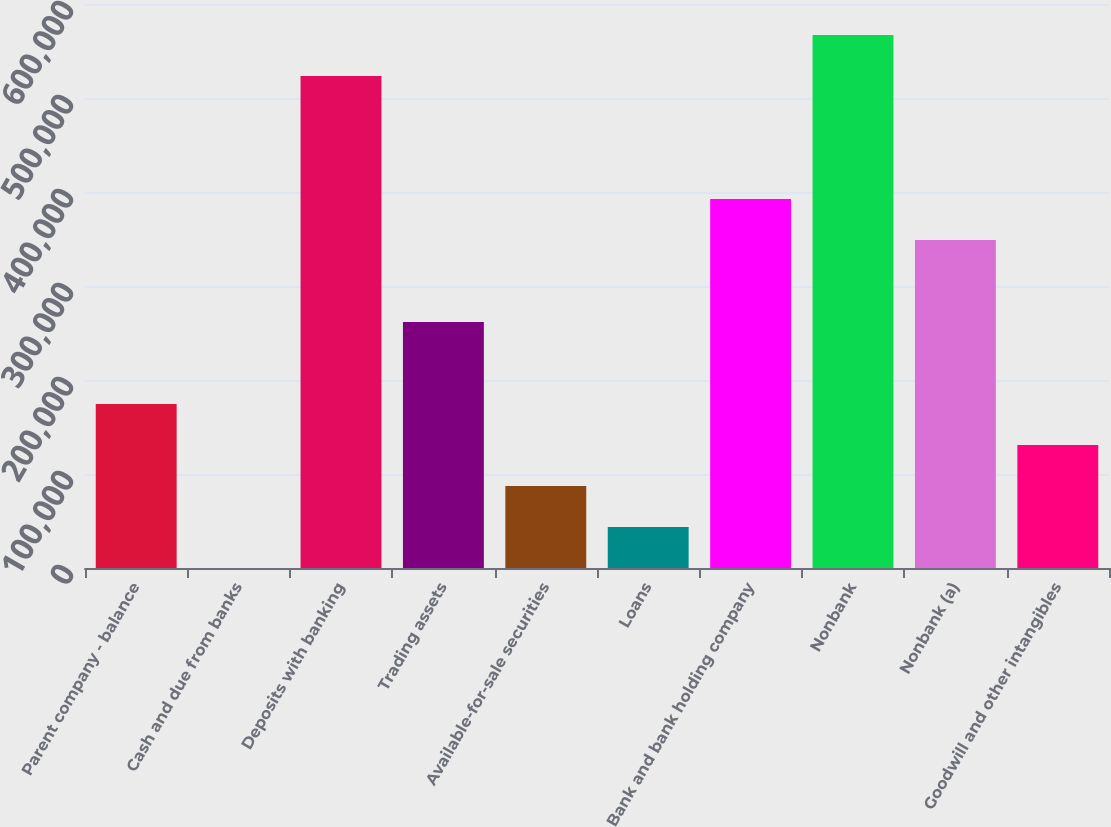<chart> <loc_0><loc_0><loc_500><loc_500><bar_chart><fcel>Parent company - balance<fcel>Cash and due from banks<fcel>Deposits with banking<fcel>Trading assets<fcel>Available-for-sale securities<fcel>Loans<fcel>Bank and bank holding company<fcel>Nonbank<fcel>Nonbank (a)<fcel>Goodwill and other intangibles<nl><fcel>174488<fcel>35<fcel>523395<fcel>261715<fcel>87261.6<fcel>43648.3<fcel>392555<fcel>567008<fcel>348941<fcel>130875<nl></chart> 